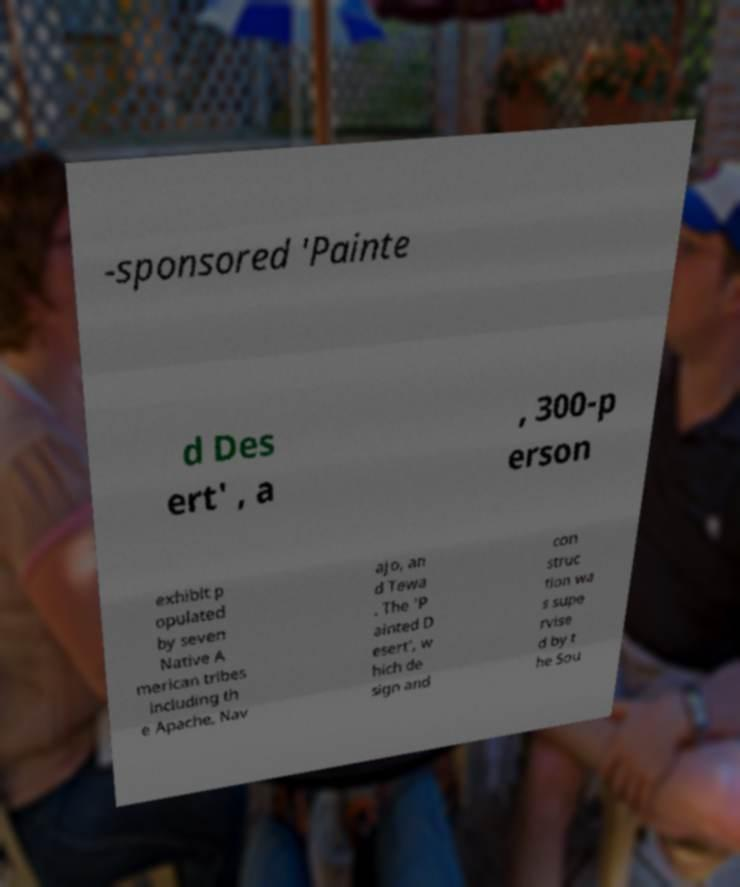Can you read and provide the text displayed in the image?This photo seems to have some interesting text. Can you extract and type it out for me? -sponsored 'Painte d Des ert' , a , 300-p erson exhibit p opulated by seven Native A merican tribes including th e Apache, Nav ajo, an d Tewa . The 'P ainted D esert', w hich de sign and con struc tion wa s supe rvise d by t he Sou 